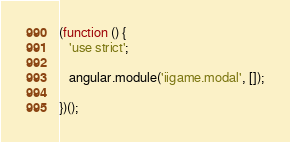Convert code to text. <code><loc_0><loc_0><loc_500><loc_500><_JavaScript_>(function () {
   'use strict';

   angular.module('iigame.modal', []);

})();
</code> 